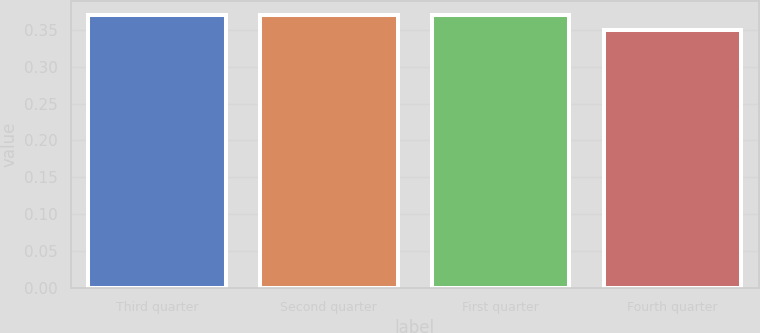<chart> <loc_0><loc_0><loc_500><loc_500><bar_chart><fcel>Third quarter<fcel>Second quarter<fcel>First quarter<fcel>Fourth quarter<nl><fcel>0.37<fcel>0.37<fcel>0.37<fcel>0.35<nl></chart> 